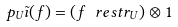<formula> <loc_0><loc_0><loc_500><loc_500>p _ { U } \tilde { \imath } ( f ) = ( f \ r e s t r _ { U } ) \otimes 1</formula> 